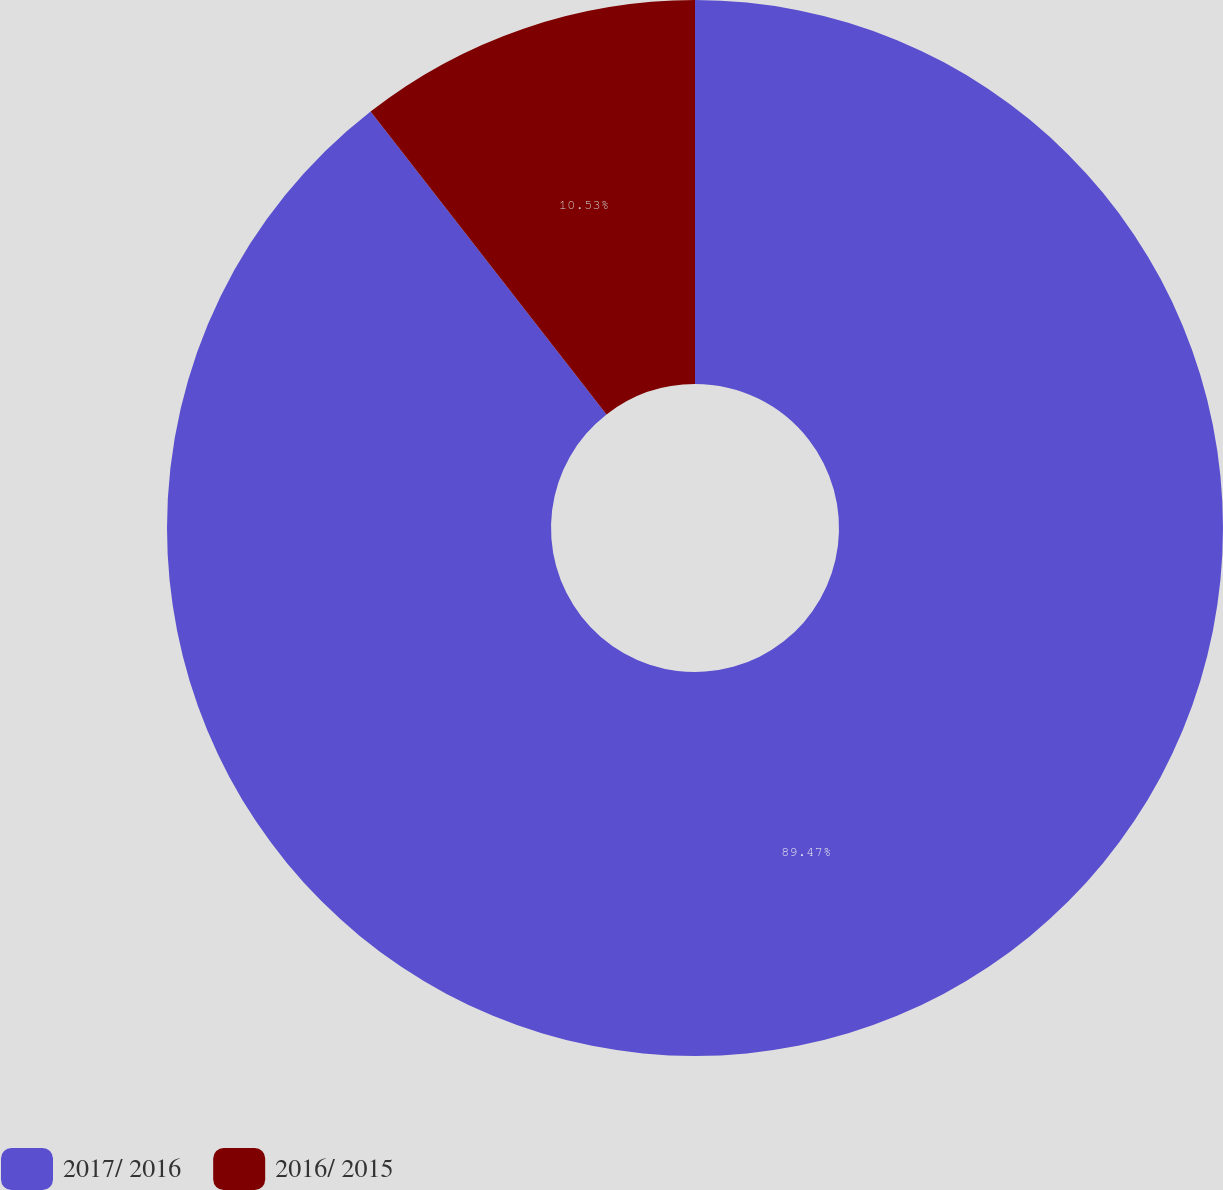<chart> <loc_0><loc_0><loc_500><loc_500><pie_chart><fcel>2017/ 2016<fcel>2016/ 2015<nl><fcel>89.47%<fcel>10.53%<nl></chart> 